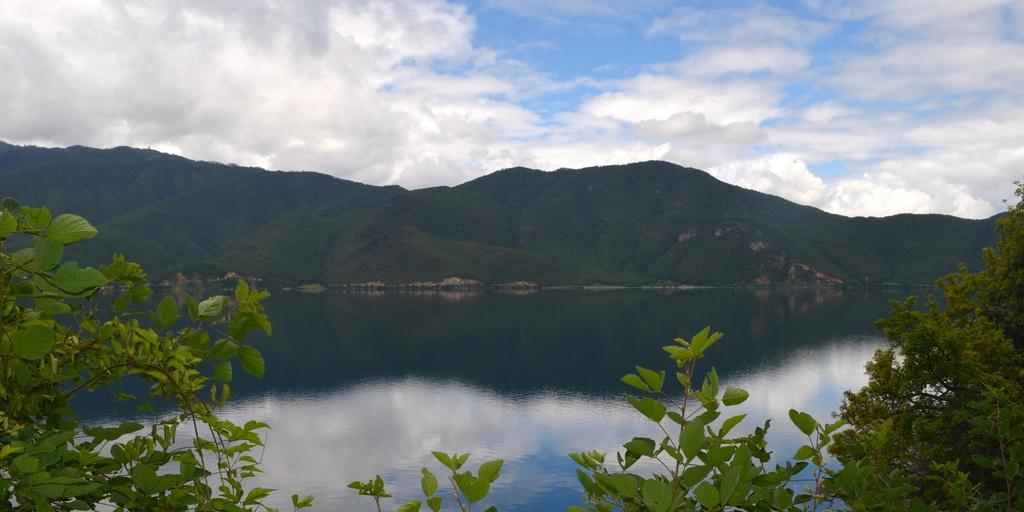What type of vegetation can be seen in the image? There are trees in the image. What natural feature is visible in the image? There is water visible in the image. What geographical feature can be seen in the image? There are hills in the image. What is visible in the sky in the image? The sky is visible in the image, and clouds are present. How many cars are parked near the trees in the image? There are no cars present in the image; it features trees, water, hills, and a sky with clouds. Can you see a frog sitting on one of the hills in the image? There is no frog present in the image; it only features trees, water, hills, and a sky with clouds. 